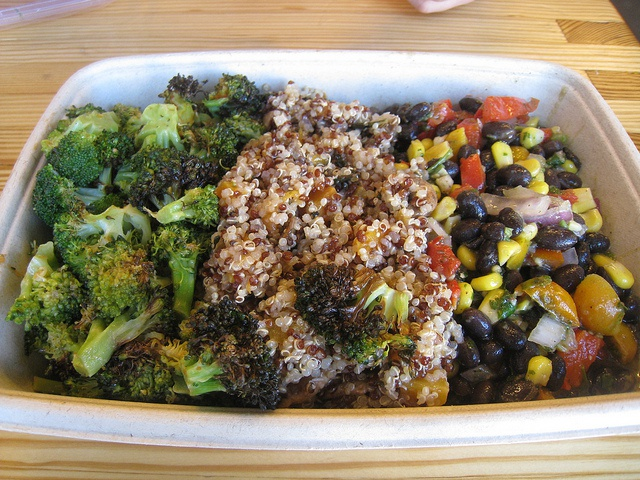Describe the objects in this image and their specific colors. I can see bowl in darkgray, black, lightgray, olive, and tan tones, dining table in darkgray and tan tones, broccoli in darkgray, olive, black, and darkgreen tones, broccoli in darkgray, black, olive, maroon, and gray tones, and broccoli in darkgray, black, darkgreen, gray, and olive tones in this image. 